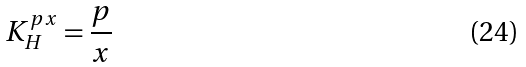<formula> <loc_0><loc_0><loc_500><loc_500>K _ { H } ^ { p x } = \frac { p } { x }</formula> 